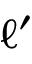<formula> <loc_0><loc_0><loc_500><loc_500>\ell ^ { \prime }</formula> 